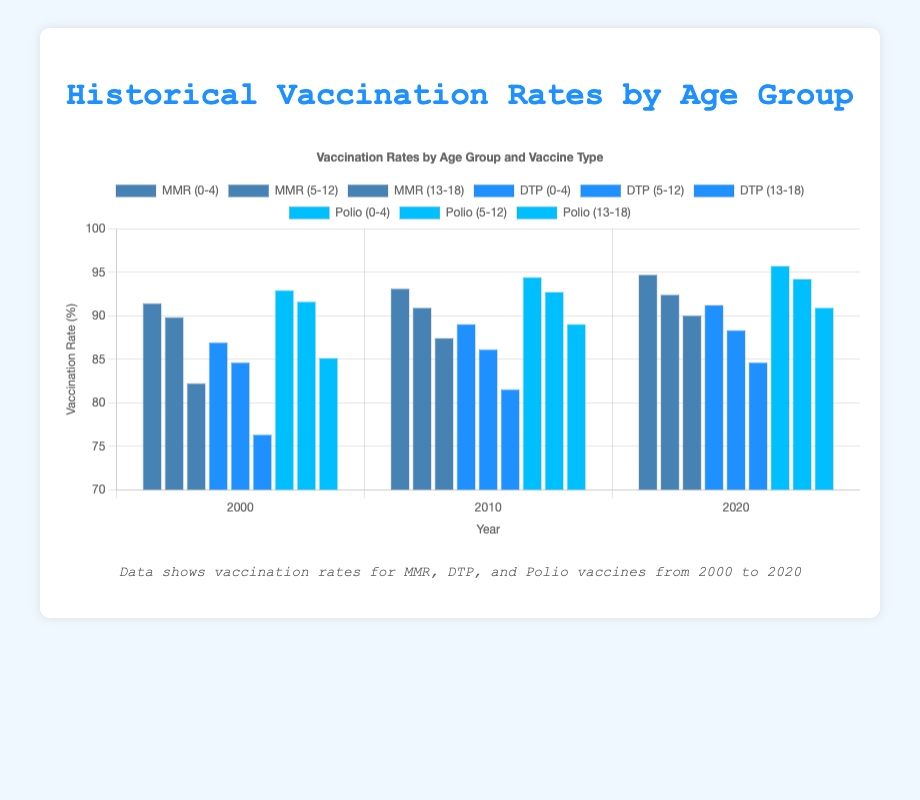What was the MMR vaccination rate for the age group 0-4 in 2020? According to the chart, locate the bar representing the MMR vaccination rate for age group 0-4 in the year 2020.
Answer: 94.8% Compare the DTP vaccination rate for the age group 5-12 between 2000 and 2020. By how much did it increase or decrease? Identify the bars representing the DTP vaccination rates for the age group 5-12 in 2000 and 2020. Subtract the 2000 rate from the 2020 rate to find the difference.
Answer: 88.4% - 84.7% = 3.7% increase What is the average vaccination rate for Polio across all age groups in 2020? Locate the Polio vaccination rates for age groups 0-4, 5-12, and 13-18 in 2020. Sum these rates and divide by the number of age groups to get the average.
Answer: (95.8% + 94.3% + 91.0%) / 3 = 93.7% Is the vaccination rate for MMR higher or lower than for DTP for the age group 0-4 in 2010? Look at the bars representing MMR and DTP vaccination rates for age group 0-4 in 2010 and compare their heights.
Answer: Higher (MMR 93.2% vs DTP 89.1%) Did the overall trend for vaccination rates improve, decline or stay consistent for the age group 5-12 from 2000 to 2020? Review the vaccination rates for all vaccines (MMR, DTP, Polio) for the age group 5-12 at years 2000, 2010, and 2020. Determine if there is an upward, downward, or consistent trend.
Answer: Improved Which age group had the lowest DTP vaccination rate in 2000 and what was the rate? Look at the bars representing DTP vaccination rates in 2000 and identify the age group with the lowest rate.
Answer: 76.4% (age group 13-18) How did the vaccination rates for Polio change for the age group 0-4 from 2000 to 2020? Locate the bars representing Polio vaccination rates for the age group 0-4 in 2000 and 2020. Compute the difference between these two rates.
Answer: 95.8% - 93.0% = 2.8% increase 